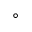<formula> <loc_0><loc_0><loc_500><loc_500>^ { \circ }</formula> 